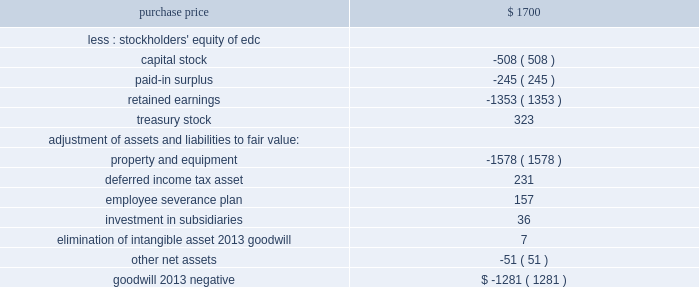Over 1 million customers .
Edc also provides 2265 mw of installed capacity through its generation facilities in venezuela .
The purchase price allocation was as follows ( in millions ) : .
Property and equipment was reduced by the negative goodwill .
The cost of the acquisition was allocated on the basis of estimated fair value of the assets acquired and liabilities assumed , primarily based upon an independent appraisal .
As of december 31 , 2000 , the severance plan was completed and the workforce was reduced by approximately 2500 people .
All of the costs associated with the plan were recorded during 2000 , and all of the cash payments were made in 2000 .
In august 2000 , a subsidiary of the company completed the acquisition of a 59% ( 59 % ) equity interest in a hidroelectrica alicura s.a .
( 2018 2018alicura 2019 2019 ) in argentina from southern energy , inc .
And its partners .
Alicura operates a 1000 mw peaking hydro facility located in the province of neuquen , argentina .
The purchase price of approximately $ 205 million includes the assumption of existing non-recourse debt .
In december 2000 a subsidiary of the company acquired an additional 39% ( 39 % ) ownership interest in alicura , 19.5% ( 19.5 % ) ownership interests each from the federal government of argentina and the province of neuquen , for approximately $ 9 million .
At december 31 , 2000 , the company 2019s ownership interest was 98% ( 98 % ) .
The employees of alicura own the remaining 2% ( 2 % ) .
All of the purchase price was allocated to property , plant and equipment and is being depreciated over the useful life .
In october 2000 , a subsidiary of the company completed the acquisition of reliant energy international 2019s 50% ( 50 % ) interest in el salvador energy holdings , s.a .
( 2018 2018eseh 2019 2019 ) that owns three distribution companies in el salvador .
The purchase price for this interest in eseh was approximately $ 173 million .
The three distribution companies , compania de alumbrado electrico de san salvador , s.a .
De c.v. , empresa electrica de oriente , s.a .
De c.v .
And distribuidora electrica de usulutan , s.a .
De c.v .
Serve 3.5 million people , approximately 60% ( 60 % ) of the population of el salvador , including the capital city of san salvador .
A subsidiary of the company had previously acquired a 50% ( 50 % ) interest in eseh through its acquisition of edc .
Through the purchase of reliant energy international 2019s ownership interest , the company owns a controlling interest in the three distribution companies .
The total purchase price for 100% ( 100 % ) of the interest in eseh approximated $ 325 million , of which approximately $ 176 million was allocated to goodwill and is being amortized over 40 years .
In december 2000 , the company acquired all of the outstanding shares of kmr power corporation ( 2018 2018kmr 2019 2019 ) , including the buyout of a minority partner in one of kmr 2019s subsidiaries , for approximately $ 64 million and assumed long-term liabilities of approximately $ 245 million .
The acquisition was financed through the issuance of approximately 699000 shares of aes common stock and cash .
Kmr owns a controlling interest in two gas-fired power plants located in cartagena , colombia : a 100% ( 100 % ) interest in the 314 mw termocandelaria power plant and a 66% ( 66 % ) interest in the 100 .
What percentage of the purchase price was treasury stock? 
Computations: (323 / 1700)
Answer: 0.19. 